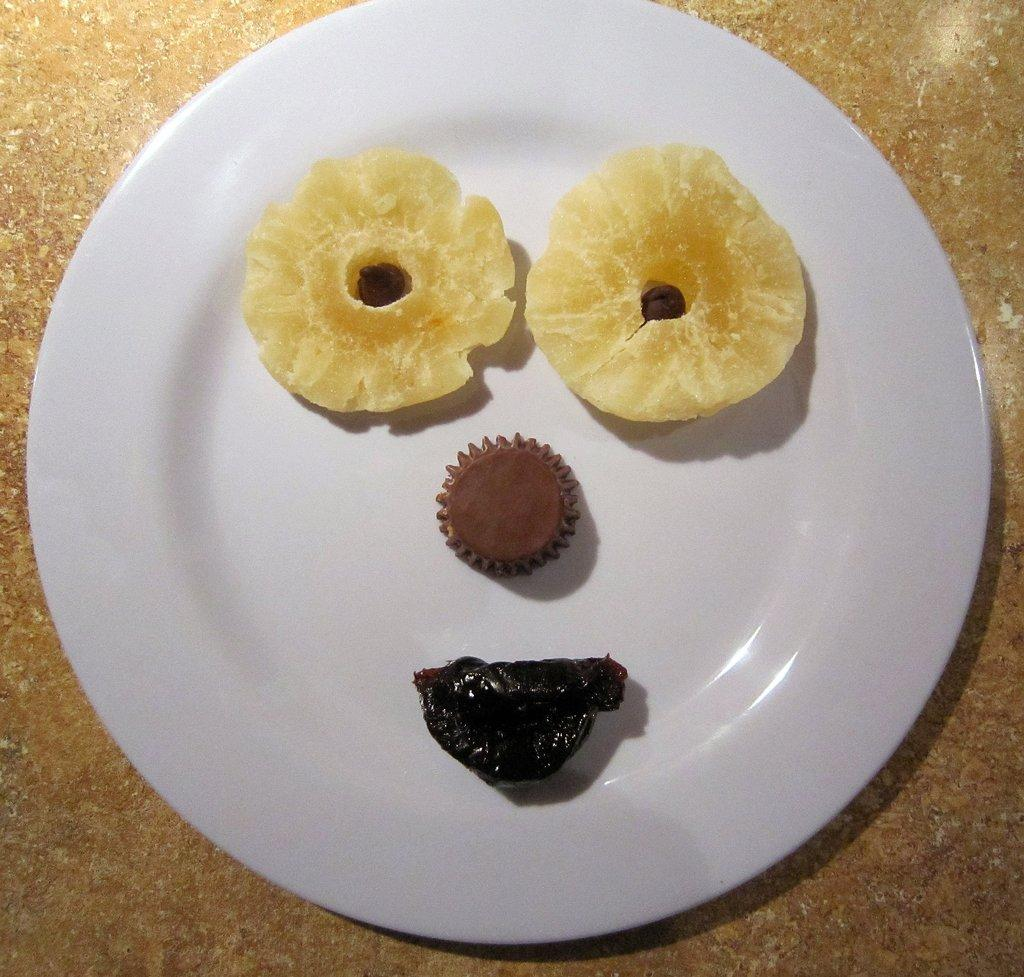What object is present in the image that is used for holding food? There is a plate in the image that is used for holding food. What is on the plate in the image? There is food placed on the plate in the image. Where is the plate located in the image? The plate is placed on a surface of the floor in the image. What type of basketball is visible on the plate in the image? There is no basketball present on the plate in the image; it is a plate with food. Is there a lamp illuminating the plate in the image? There is no lamp present in the image; it only shows a plate with food placed on the floor. 